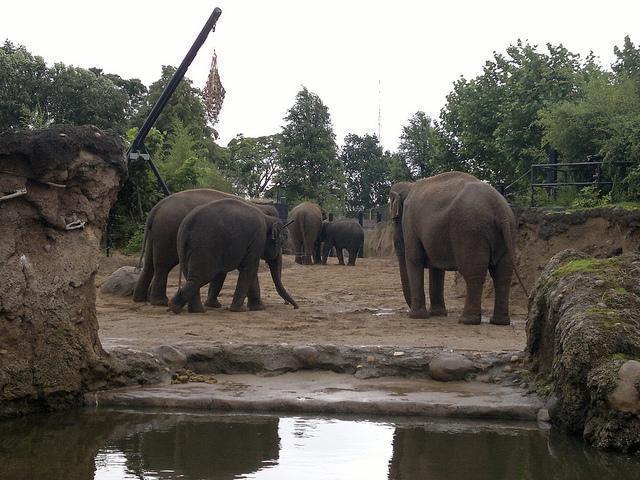What measurement is closest to the weight of the biggest animal here?
Answer the question by selecting the correct answer among the 4 following choices.
Options: 5 milligrams, 3 kilograms, 8000 pounds, 500 tons. 5 milligrams. 